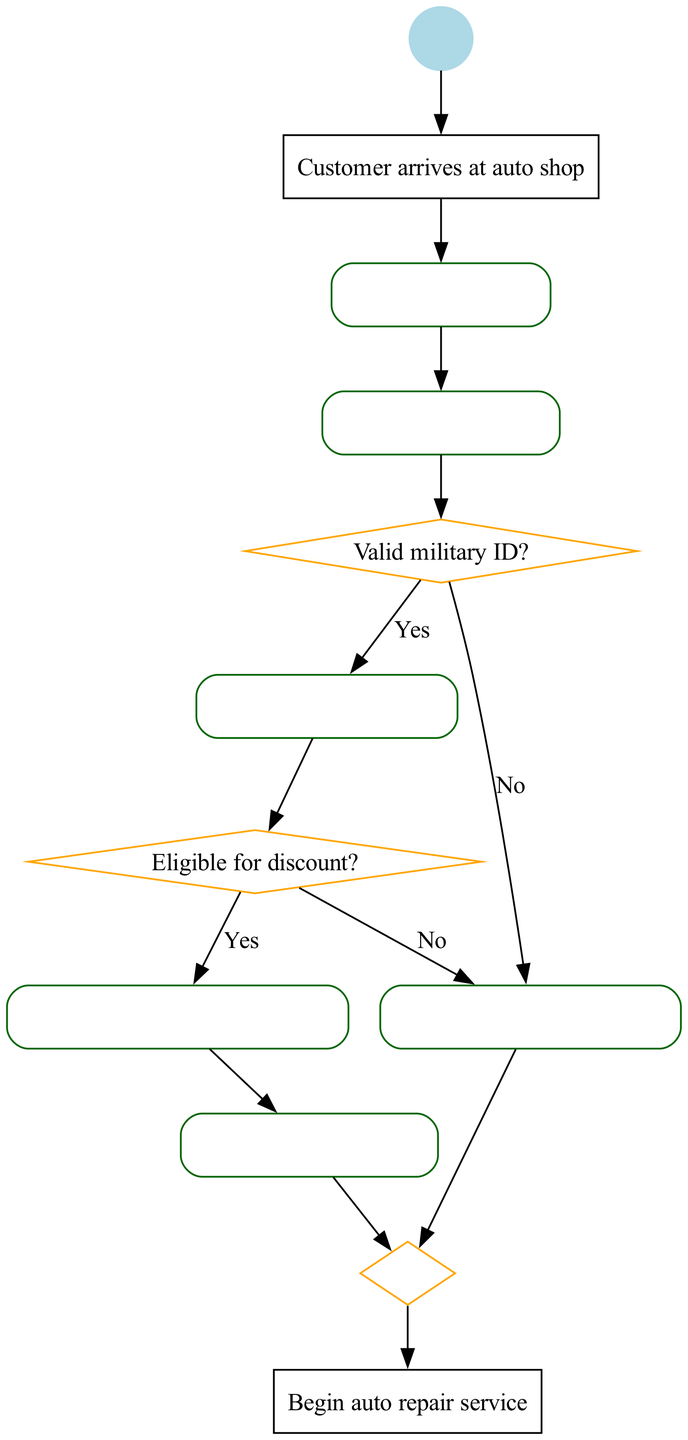What is the first activity after the customer arrives at the auto shop? The first activity listed in the diagram following "Customer arrives at auto shop" is "Request military ID." This can be directly seen as the first activity connected from the initial node.
Answer: Request military ID How many activities are there in the diagram? Counting the activities presented in the diagram, there are a total of six activities listed. They are: Request military ID, Verify ID authenticity, Check service eligibility, Enter customer details in system, Apply military discount, and Proceed with regular service.
Answer: Six What happens if the military ID is not valid? If the military ID is not valid, the flow goes to the "Proceed with regular service" activity. This is indicated by the decision node which branches out to this activity when answered negatively.
Answer: Proceed with regular service What is the decision made after verifying the military ID? After verifying the military ID, the next decision is "Eligible for discount?" This follows the verification activity and leads to determining if a discount is applicable or not.
Answer: Eligible for discount? How many end nodes are there in the diagram? The diagram features one end node which signifies the completion of the process, leading to "Begin auto repair service." This indicates that there is only one defined endpoint.
Answer: One What activity directly follows "Check service eligibility"? The activity that follows "Check service eligibility" is "Enter customer details in system." This is a linear progression observed from the activities defined in the diagram.
Answer: Enter customer details in system What is the outcome if the customer is eligible for a discount? If the customer is eligible for a discount, the process leads to the activity "Apply military discount." This follows the positive outcome of the decision regarding eligibility for the discount.
Answer: Apply military discount Which activity occurs after applying the military discount? After applying the military discount, the next step is "Proceed with regular service," indicating that the service continues after the discount application.
Answer: Proceed with regular service What type of node connects the activities together? The activities are connected by directed edges that guide the flow from one activity to the next, facilitating the sequence of the process. This showcases the relationship between activities visually in the diagram.
Answer: Directed edges 